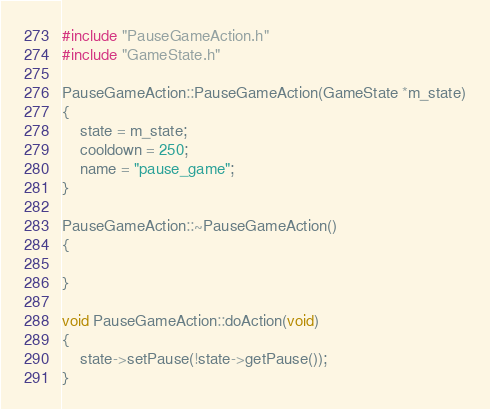Convert code to text. <code><loc_0><loc_0><loc_500><loc_500><_C++_>#include "PauseGameAction.h"
#include "GameState.h"

PauseGameAction::PauseGameAction(GameState *m_state)
{
    state = m_state;
    cooldown = 250;
    name = "pause_game";
}

PauseGameAction::~PauseGameAction()
{

}

void PauseGameAction::doAction(void)
{
    state->setPause(!state->getPause());
}
</code> 